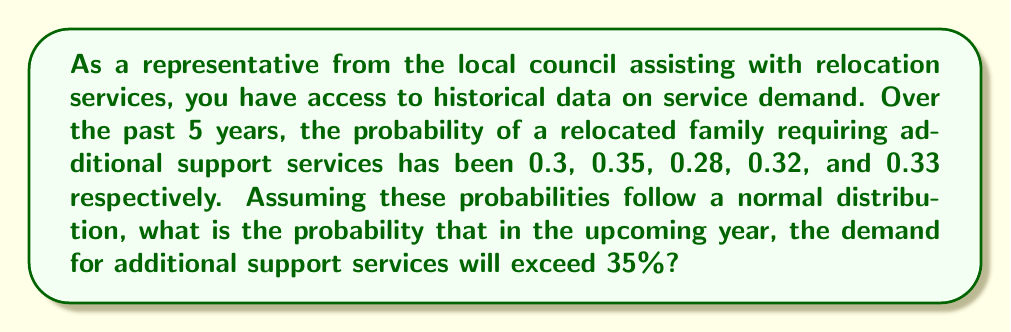What is the answer to this math problem? To solve this problem, we need to use the properties of the normal distribution and the z-score calculation. Let's break it down step by step:

1. Calculate the mean ($\mu$) of the probabilities:
   $$\mu = \frac{0.3 + 0.35 + 0.28 + 0.32 + 0.33}{5} = 0.316$$

2. Calculate the standard deviation ($\sigma$) of the probabilities:
   $$\sigma = \sqrt{\frac{\sum (x_i - \mu)^2}{n-1}}$$
   $$\sigma = \sqrt{\frac{(0.3-0.316)^2 + (0.35-0.316)^2 + (0.28-0.316)^2 + (0.32-0.316)^2 + (0.33-0.316)^2}{5-1}}$$
   $$\sigma = \sqrt{\frac{0.000256 + 0.001156 + 0.001296 + 0.000016 + 0.000196}{4}} = 0.02608$$

3. Calculate the z-score for the target probability (0.35):
   $$z = \frac{x - \mu}{\sigma} = \frac{0.35 - 0.316}{0.02608} = 1.3038$$

4. Use the standard normal distribution table or a calculator to find the probability of a z-score greater than 1.3038.

5. The area to the right of z = 1.3038 in a standard normal distribution is approximately 0.0962.

Therefore, the probability that the demand for additional support services will exceed 35% in the upcoming year is approximately 0.0962 or 9.62%.
Answer: The probability that the demand for additional support services will exceed 35% in the upcoming year is approximately 0.0962 or 9.62%. 